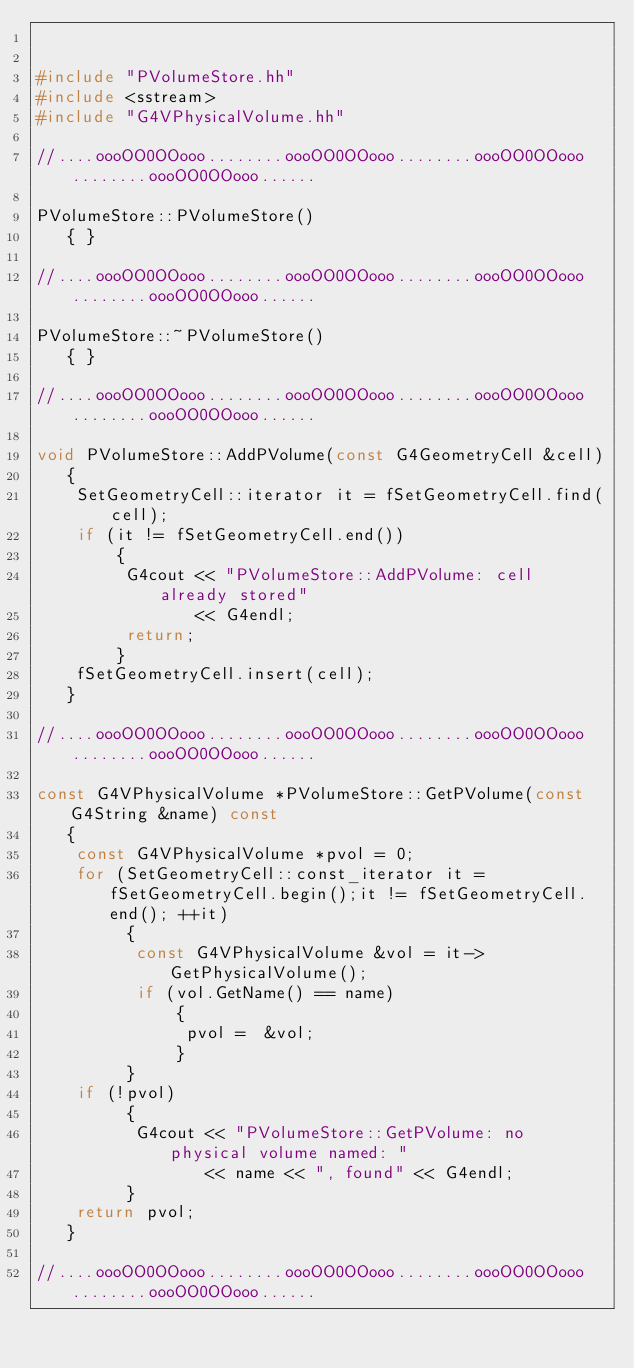Convert code to text. <code><loc_0><loc_0><loc_500><loc_500><_C++_>

#include "PVolumeStore.hh"
#include <sstream>
#include "G4VPhysicalVolume.hh"

//....oooOO0OOooo........oooOO0OOooo........oooOO0OOooo........oooOO0OOooo......

PVolumeStore::PVolumeStore()
   { }

//....oooOO0OOooo........oooOO0OOooo........oooOO0OOooo........oooOO0OOooo......

PVolumeStore::~PVolumeStore()
   { }

//....oooOO0OOooo........oooOO0OOooo........oooOO0OOooo........oooOO0OOooo......
  
void PVolumeStore::AddPVolume(const G4GeometryCell &cell)
   {
    SetGeometryCell::iterator it = fSetGeometryCell.find(cell);
    if (it != fSetGeometryCell.end()) 
        {
         G4cout << "PVolumeStore::AddPVolume: cell already stored" 
                << G4endl;
         return;
        } 
    fSetGeometryCell.insert(cell);
   }

//....oooOO0OOooo........oooOO0OOooo........oooOO0OOooo........oooOO0OOooo......

const G4VPhysicalVolume *PVolumeStore::GetPVolume(const G4String &name) const 
   {
    const G4VPhysicalVolume *pvol = 0;
    for (SetGeometryCell::const_iterator it = fSetGeometryCell.begin();it != fSetGeometryCell.end(); ++it) 
         {
          const G4VPhysicalVolume &vol = it->GetPhysicalVolume();
          if (vol.GetName() == name) 
              {
               pvol =  &vol;
              } 
         }
    if (!pvol)
         {
          G4cout << "PVolumeStore::GetPVolume: no physical volume named: " 
                 << name << ", found" << G4endl;
         }
    return pvol;
   }

//....oooOO0OOooo........oooOO0OOooo........oooOO0OOooo........oooOO0OOooo......
</code> 